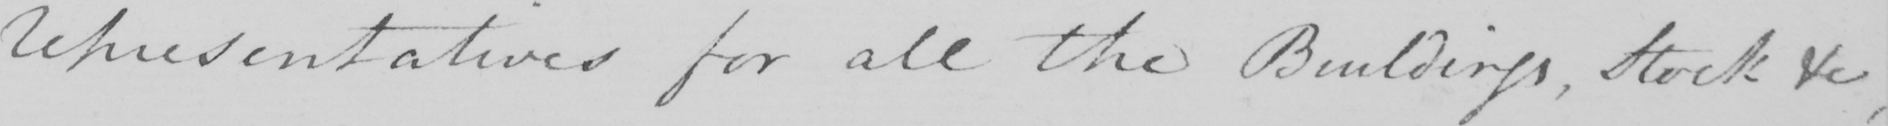Transcribe the text shown in this historical manuscript line. Representatives for all the Buildings , Stock &c , 